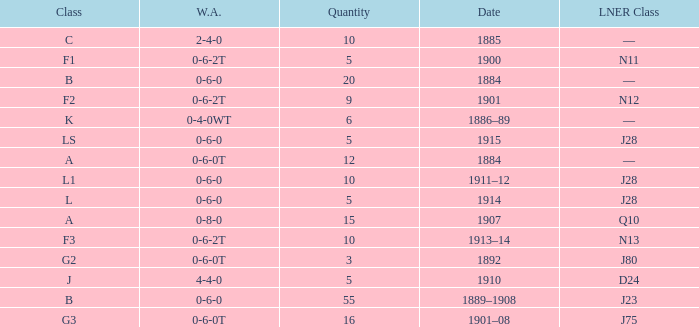Can you give me this table as a dict? {'header': ['Class', 'W.A.', 'Quantity', 'Date', 'LNER Class'], 'rows': [['C', '2-4-0', '10', '1885', '—'], ['F1', '0-6-2T', '5', '1900', 'N11'], ['B', '0-6-0', '20', '1884', '—'], ['F2', '0-6-2T', '9', '1901', 'N12'], ['K', '0-4-0WT', '6', '1886–89', '—'], ['LS', '0-6-0', '5', '1915', 'J28'], ['A', '0-6-0T', '12', '1884', '—'], ['L1', '0-6-0', '10', '1911–12', 'J28'], ['L', '0-6-0', '5', '1914', 'J28'], ['A', '0-8-0', '15', '1907', 'Q10'], ['F3', '0-6-2T', '10', '1913–14', 'N13'], ['G2', '0-6-0T', '3', '1892', 'J80'], ['J', '4-4-0', '5', '1910', 'D24'], ['B', '0-6-0', '55', '1889–1908', 'J23'], ['G3', '0-6-0T', '16', '1901–08', 'J75']]} What class is associated with a W.A. of 0-8-0? A. 